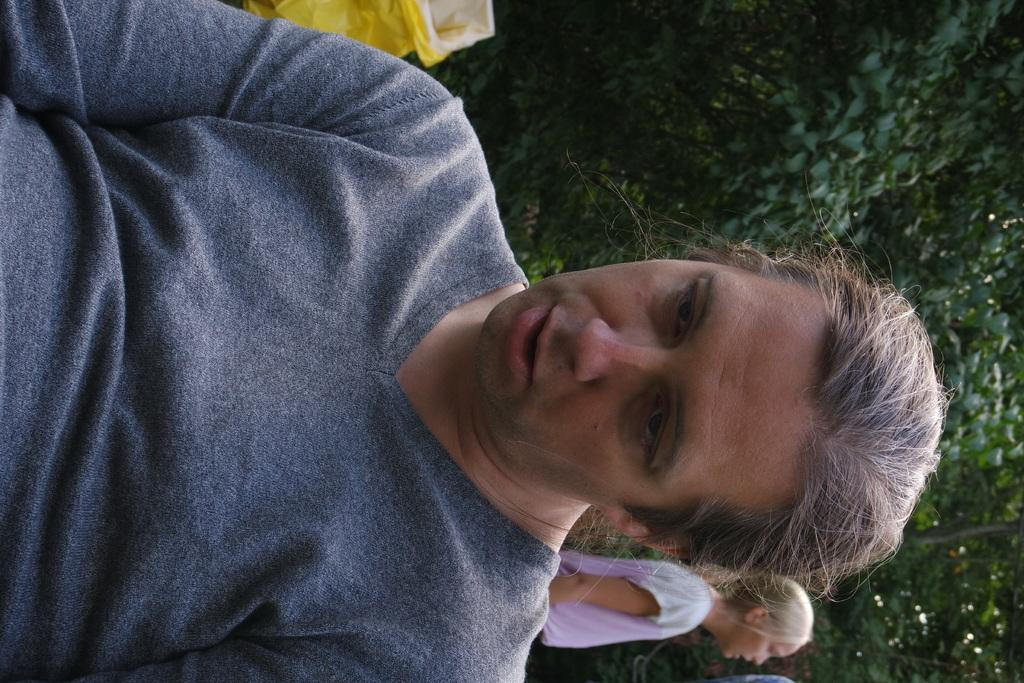How is the image oriented? The image is tilted. What is the person in the image doing? There is a person sitting on a chair in the image. What can be seen in the background of the image? There are people standing and trees in the background of the image. What object is visible in the image? There is a bag visible in the image. What is the profit of the person sitting on the chair in the image? There is no mention of profit in the image, so it cannot be determined. --- Facts: 1. There is a person standing in the image. 2. The person is holding a book. 3. The book has a blue cover. 4. The person is standing in front of a bookshelf. 5. The bookshelf has multiple books on it. Absurd Topics: elephant, ocean, submarine Conversation: What is the main subject in the image? There is a person standing in the image. What is the person holding in the image? The person is holding a book. What can be said about the book's cover? The book has a blue cover. What is visible in the background of the image? The person is standing in front of a bookshelf. How many books are visible on the bookshelf? The bookshelf has multiple books on it. Reasoning: Let's think step by step in order to ${produce the conversation}. We start by identifying the main subject of the image, which is the person standing. Next, we describe what the person is holding, which is a book. Then, we observe and mention the color of the book's cover, which is blue. After that, we focus on the background of the image, which features a bookshelf. Finally, we count and mention the number of books visible on the bookshelf, which is multiple books. Absurd Question/Answer: Can you see an elephant swimming in the ocean in the image? There is no elephant or ocean present in the image. 